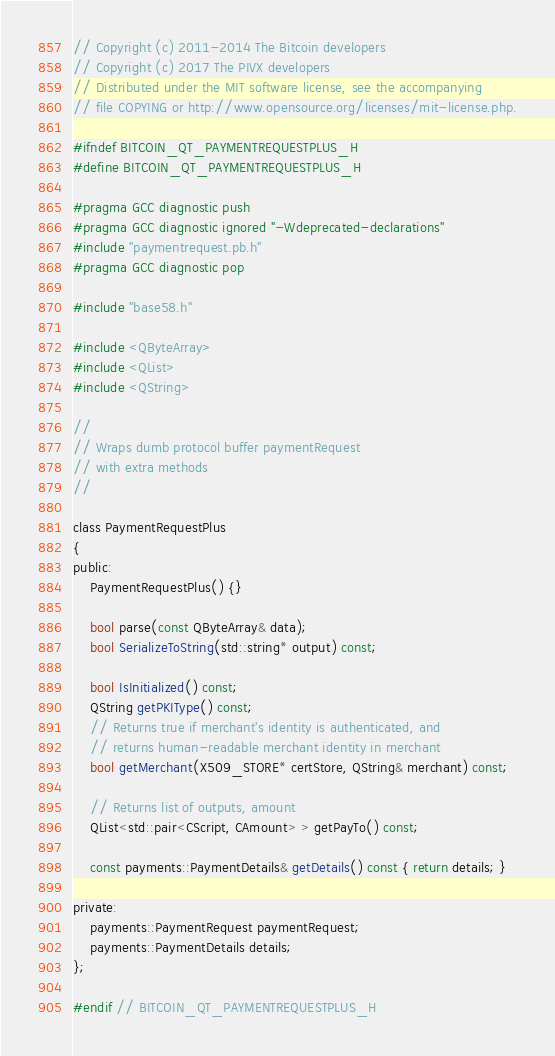<code> <loc_0><loc_0><loc_500><loc_500><_C_>// Copyright (c) 2011-2014 The Bitcoin developers
// Copyright (c) 2017 The PIVX developers
// Distributed under the MIT software license, see the accompanying
// file COPYING or http://www.opensource.org/licenses/mit-license.php.

#ifndef BITCOIN_QT_PAYMENTREQUESTPLUS_H
#define BITCOIN_QT_PAYMENTREQUESTPLUS_H

#pragma GCC diagnostic push
#pragma GCC diagnostic ignored "-Wdeprecated-declarations"
#include "paymentrequest.pb.h"
#pragma GCC diagnostic pop

#include "base58.h"

#include <QByteArray>
#include <QList>
#include <QString>

//
// Wraps dumb protocol buffer paymentRequest
// with extra methods
//

class PaymentRequestPlus
{
public:
    PaymentRequestPlus() {}

    bool parse(const QByteArray& data);
    bool SerializeToString(std::string* output) const;

    bool IsInitialized() const;
    QString getPKIType() const;
    // Returns true if merchant's identity is authenticated, and
    // returns human-readable merchant identity in merchant
    bool getMerchant(X509_STORE* certStore, QString& merchant) const;

    // Returns list of outputs, amount
    QList<std::pair<CScript, CAmount> > getPayTo() const;

    const payments::PaymentDetails& getDetails() const { return details; }

private:
    payments::PaymentRequest paymentRequest;
    payments::PaymentDetails details;
};

#endif // BITCOIN_QT_PAYMENTREQUESTPLUS_H
</code> 